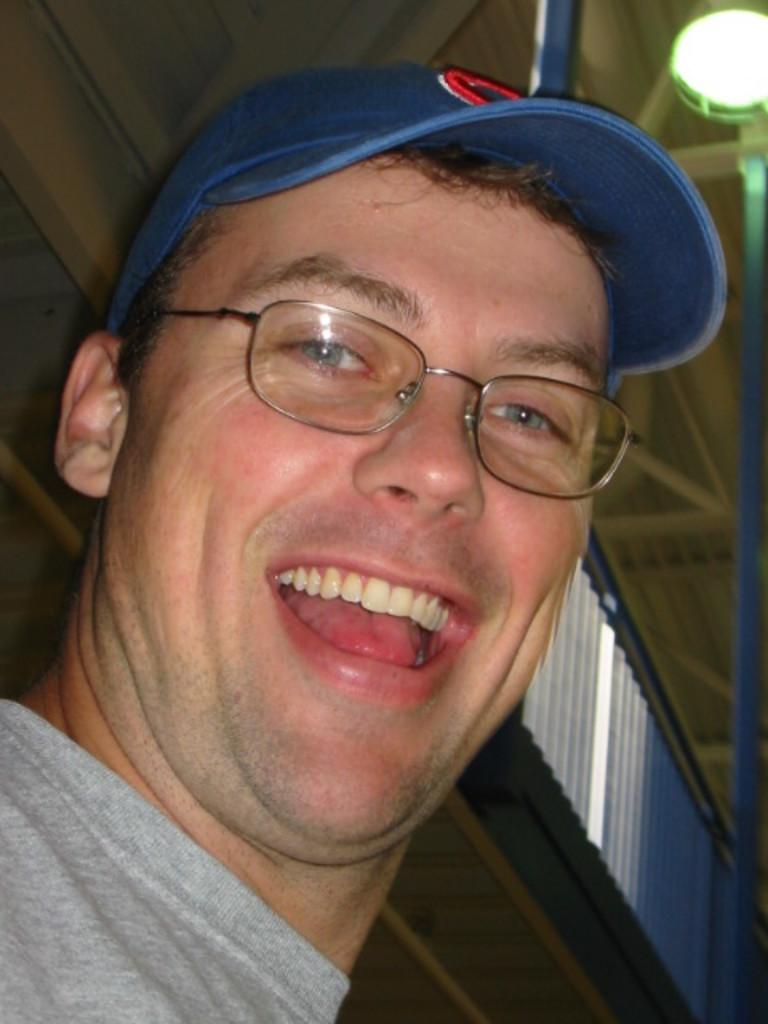What is the main subject of the image? The main subject of the image is a man. Can you describe the man's appearance? The man is wearing spectacles and a cap. What is the man's facial expression? The man is smiling. What can be seen behind the man? There is a wall behind the man. What is visible above the man? There is a ceiling with lights in the image. Can you tell me how many ducks are present in the image? There are no ducks present in the image; it features a man wearing spectacles and a cap, smiling, with a wall behind him and a ceiling with lights above. 